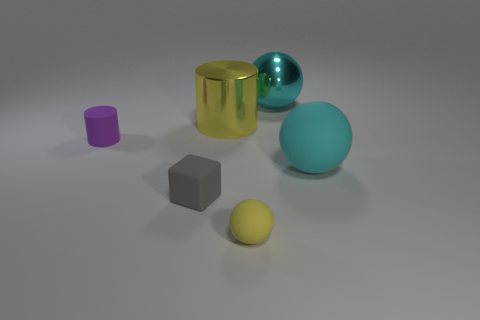Add 1 tiny brown metal things. How many objects exist? 7 Subtract all cylinders. How many objects are left? 4 Subtract 0 green balls. How many objects are left? 6 Subtract all objects. Subtract all large gray shiny spheres. How many objects are left? 0 Add 3 large cyan matte balls. How many large cyan matte balls are left? 4 Add 1 cyan objects. How many cyan objects exist? 3 